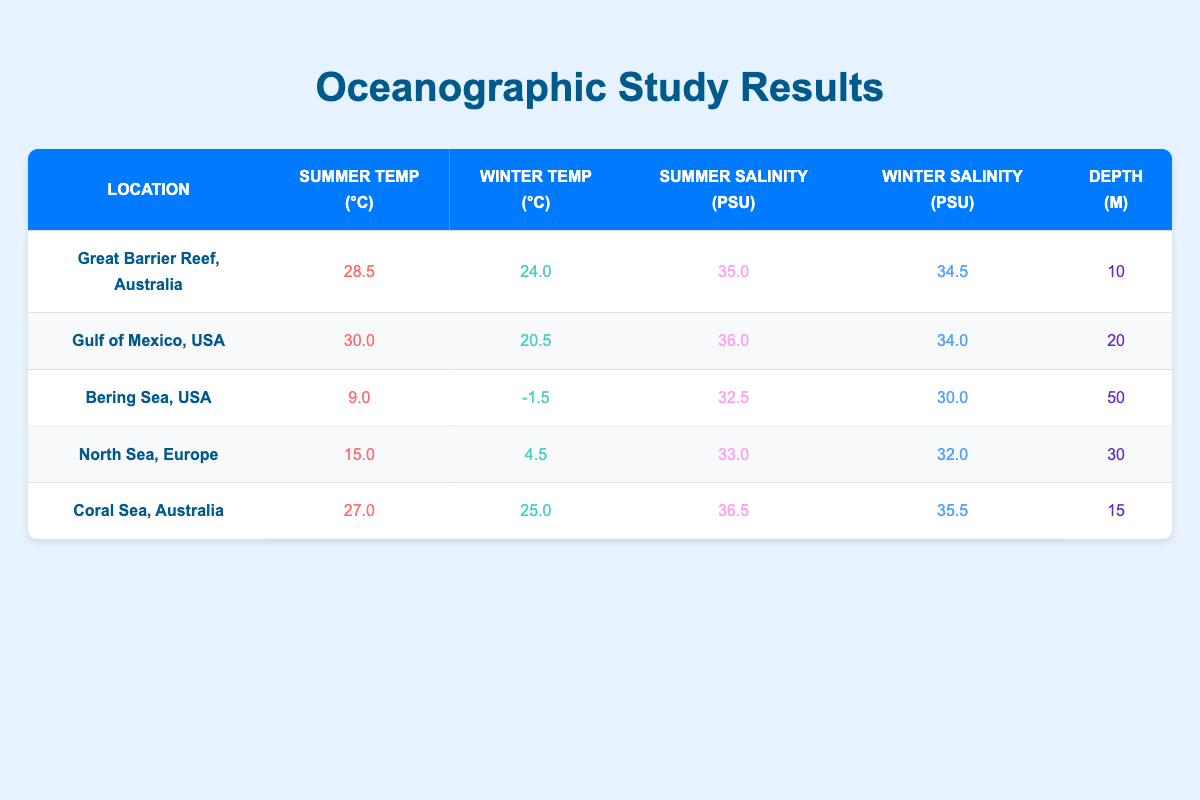What is the summer temperature in the Gulf of Mexico? The table shows the summer temperature for the Gulf of Mexico listed under the Summer Temp (°C) column, which is 30.0.
Answer: 30.0 What is the winter salinity of the Great Barrier Reef? According to the table, the winter salinity for the Great Barrier Reef is found in the Winter Salinity (PSU) column, which is 34.5.
Answer: 34.5 Which location has the highest summer temperature? By comparing the summer temperatures from the Summer Temp (°C) column for all locations, the Gulf of Mexico has the highest at 30.0°C.
Answer: Gulf of Mexico, USA What is the difference in winter temperatures between the Great Barrier Reef and North Sea? The winter temperature for the Great Barrier Reef is 24.0°C and for the North Sea it is 4.5°C. The difference is calculated as 24.0 - 4.5 = 19.5°C.
Answer: 19.5°C Is the salinity in the Coral Sea greater in summer than in winter? The table indicates that the summer salinity for the Coral Sea is 36.5 and the winter salinity is 35.5, making the summer salinity greater.
Answer: Yes What is the average summer salinity across all the listed locations? To find the average, sum the summer salinities: (35.0 + 36.0 + 32.5 + 33.0 + 36.5) = 173.0. Then divide by the number of locations, which is 5: 173.0 / 5 = 34.6.
Answer: 34.6 Which location has the lowest winter temperature? The Bering Sea has the lowest winter temperature at -1.5°C, as shown in the Winter Temp (°C) column.
Answer: Bering Sea, USA What is the depth of the location with the highest summer salinity? The Coral Sea has the highest summer salinity of 36.5 PSU. Its depth is listed as 15 meters.
Answer: 15 meters Does the Gulf of Mexico have a colder winter temperature than the North Sea? The Gulf of Mexico's winter temperature is 20.5°C, while the North Sea's is 4.5°C. Since 20.5 is greater than 4.5, the statement is false.
Answer: No 